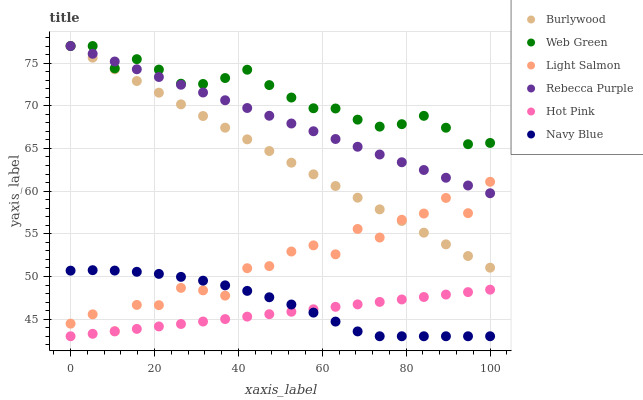Does Hot Pink have the minimum area under the curve?
Answer yes or no. Yes. Does Web Green have the maximum area under the curve?
Answer yes or no. Yes. Does Burlywood have the minimum area under the curve?
Answer yes or no. No. Does Burlywood have the maximum area under the curve?
Answer yes or no. No. Is Burlywood the smoothest?
Answer yes or no. Yes. Is Light Salmon the roughest?
Answer yes or no. Yes. Is Navy Blue the smoothest?
Answer yes or no. No. Is Navy Blue the roughest?
Answer yes or no. No. Does Navy Blue have the lowest value?
Answer yes or no. Yes. Does Burlywood have the lowest value?
Answer yes or no. No. Does Rebecca Purple have the highest value?
Answer yes or no. Yes. Does Navy Blue have the highest value?
Answer yes or no. No. Is Navy Blue less than Web Green?
Answer yes or no. Yes. Is Rebecca Purple greater than Hot Pink?
Answer yes or no. Yes. Does Hot Pink intersect Navy Blue?
Answer yes or no. Yes. Is Hot Pink less than Navy Blue?
Answer yes or no. No. Is Hot Pink greater than Navy Blue?
Answer yes or no. No. Does Navy Blue intersect Web Green?
Answer yes or no. No. 